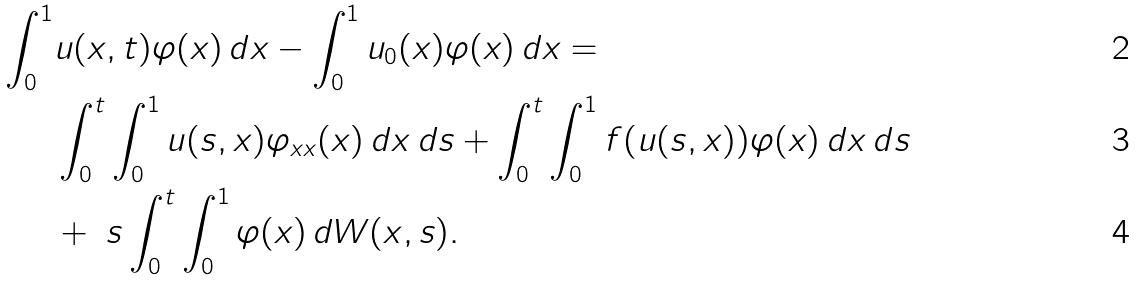Convert formula to latex. <formula><loc_0><loc_0><loc_500><loc_500>\int _ { 0 } ^ { 1 } & u ( x , t ) \varphi ( x ) \, d x - \int _ { 0 } ^ { 1 } u _ { 0 } ( x ) \varphi ( x ) \, d x = \\ & \int _ { 0 } ^ { t } \int _ { 0 } ^ { 1 } u ( s , x ) \varphi _ { x x } ( x ) \, d x \, d s + \int _ { 0 } ^ { t } \int _ { 0 } ^ { 1 } f ( u ( s , x ) ) \varphi ( x ) \, d x \, d s \\ & + \ s \int _ { 0 } ^ { t } \int _ { 0 } ^ { 1 } \varphi ( x ) \, d W ( x , s ) .</formula> 